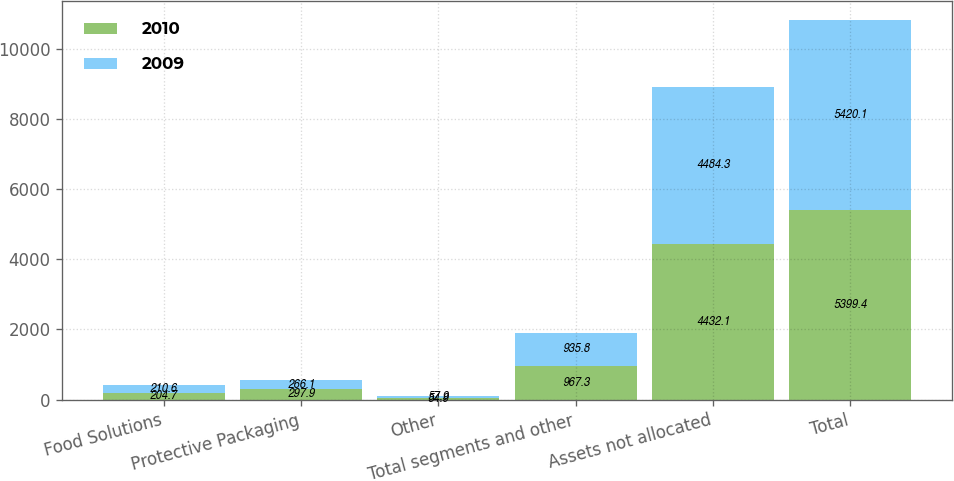Convert chart. <chart><loc_0><loc_0><loc_500><loc_500><stacked_bar_chart><ecel><fcel>Food Solutions<fcel>Protective Packaging<fcel>Other<fcel>Total segments and other<fcel>Assets not allocated<fcel>Total<nl><fcel>2010<fcel>204.7<fcel>297.9<fcel>54.9<fcel>967.3<fcel>4432.1<fcel>5399.4<nl><fcel>2009<fcel>210.6<fcel>266.1<fcel>57.9<fcel>935.8<fcel>4484.3<fcel>5420.1<nl></chart> 